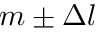Convert formula to latex. <formula><loc_0><loc_0><loc_500><loc_500>m \pm \Delta l</formula> 